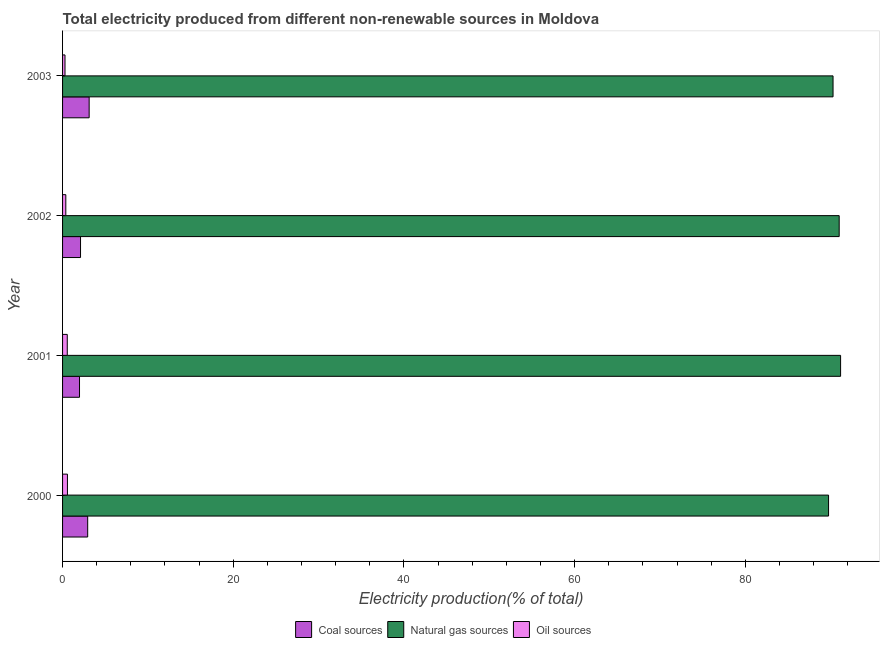How many different coloured bars are there?
Your answer should be very brief. 3. How many bars are there on the 2nd tick from the top?
Give a very brief answer. 3. How many bars are there on the 3rd tick from the bottom?
Keep it short and to the point. 3. What is the label of the 1st group of bars from the top?
Your response must be concise. 2003. In how many cases, is the number of bars for a given year not equal to the number of legend labels?
Keep it short and to the point. 0. What is the percentage of electricity produced by coal in 2001?
Your response must be concise. 1.99. Across all years, what is the maximum percentage of electricity produced by natural gas?
Give a very brief answer. 91.17. Across all years, what is the minimum percentage of electricity produced by natural gas?
Provide a succinct answer. 89.76. In which year was the percentage of electricity produced by oil sources maximum?
Your answer should be compact. 2000. What is the total percentage of electricity produced by natural gas in the graph?
Your response must be concise. 362.22. What is the difference between the percentage of electricity produced by coal in 2001 and that in 2002?
Provide a succinct answer. -0.12. What is the difference between the percentage of electricity produced by coal in 2000 and the percentage of electricity produced by natural gas in 2001?
Offer a very short reply. -88.23. What is the average percentage of electricity produced by coal per year?
Your answer should be very brief. 2.54. In the year 2000, what is the difference between the percentage of electricity produced by natural gas and percentage of electricity produced by oil sources?
Your answer should be very brief. 89.19. Is the percentage of electricity produced by oil sources in 2000 less than that in 2002?
Your answer should be very brief. No. Is the difference between the percentage of electricity produced by coal in 2001 and 2002 greater than the difference between the percentage of electricity produced by natural gas in 2001 and 2002?
Offer a very short reply. No. What is the difference between the highest and the second highest percentage of electricity produced by coal?
Offer a terse response. 0.17. What is the difference between the highest and the lowest percentage of electricity produced by coal?
Make the answer very short. 1.13. In how many years, is the percentage of electricity produced by natural gas greater than the average percentage of electricity produced by natural gas taken over all years?
Your answer should be compact. 2. What does the 2nd bar from the top in 2001 represents?
Provide a succinct answer. Natural gas sources. What does the 1st bar from the bottom in 2002 represents?
Keep it short and to the point. Coal sources. Are all the bars in the graph horizontal?
Give a very brief answer. Yes. How many years are there in the graph?
Provide a short and direct response. 4. What is the difference between two consecutive major ticks on the X-axis?
Your response must be concise. 20. Are the values on the major ticks of X-axis written in scientific E-notation?
Give a very brief answer. No. Does the graph contain any zero values?
Provide a succinct answer. No. How many legend labels are there?
Make the answer very short. 3. How are the legend labels stacked?
Give a very brief answer. Horizontal. What is the title of the graph?
Your response must be concise. Total electricity produced from different non-renewable sources in Moldova. What is the label or title of the X-axis?
Offer a terse response. Electricity production(% of total). What is the Electricity production(% of total) in Coal sources in 2000?
Ensure brevity in your answer.  2.94. What is the Electricity production(% of total) in Natural gas sources in 2000?
Offer a very short reply. 89.76. What is the Electricity production(% of total) in Oil sources in 2000?
Ensure brevity in your answer.  0.57. What is the Electricity production(% of total) in Coal sources in 2001?
Offer a terse response. 1.99. What is the Electricity production(% of total) in Natural gas sources in 2001?
Your answer should be compact. 91.17. What is the Electricity production(% of total) in Oil sources in 2001?
Ensure brevity in your answer.  0.55. What is the Electricity production(% of total) in Coal sources in 2002?
Offer a very short reply. 2.11. What is the Electricity production(% of total) in Natural gas sources in 2002?
Provide a short and direct response. 91.01. What is the Electricity production(% of total) in Oil sources in 2002?
Keep it short and to the point. 0.38. What is the Electricity production(% of total) of Coal sources in 2003?
Your response must be concise. 3.12. What is the Electricity production(% of total) of Natural gas sources in 2003?
Ensure brevity in your answer.  90.29. What is the Electricity production(% of total) in Oil sources in 2003?
Offer a very short reply. 0.28. Across all years, what is the maximum Electricity production(% of total) of Coal sources?
Offer a terse response. 3.12. Across all years, what is the maximum Electricity production(% of total) in Natural gas sources?
Your response must be concise. 91.17. Across all years, what is the maximum Electricity production(% of total) of Oil sources?
Ensure brevity in your answer.  0.57. Across all years, what is the minimum Electricity production(% of total) of Coal sources?
Your response must be concise. 1.99. Across all years, what is the minimum Electricity production(% of total) in Natural gas sources?
Keep it short and to the point. 89.76. Across all years, what is the minimum Electricity production(% of total) in Oil sources?
Ensure brevity in your answer.  0.28. What is the total Electricity production(% of total) of Coal sources in the graph?
Ensure brevity in your answer.  10.15. What is the total Electricity production(% of total) in Natural gas sources in the graph?
Ensure brevity in your answer.  362.22. What is the total Electricity production(% of total) of Oil sources in the graph?
Offer a very short reply. 1.79. What is the difference between the Electricity production(% of total) of Coal sources in 2000 and that in 2001?
Ensure brevity in your answer.  0.96. What is the difference between the Electricity production(% of total) of Natural gas sources in 2000 and that in 2001?
Your answer should be compact. -1.41. What is the difference between the Electricity production(% of total) of Coal sources in 2000 and that in 2002?
Provide a short and direct response. 0.84. What is the difference between the Electricity production(% of total) in Natural gas sources in 2000 and that in 2002?
Your answer should be compact. -1.25. What is the difference between the Electricity production(% of total) in Oil sources in 2000 and that in 2002?
Your response must be concise. 0.19. What is the difference between the Electricity production(% of total) of Coal sources in 2000 and that in 2003?
Keep it short and to the point. -0.17. What is the difference between the Electricity production(% of total) of Natural gas sources in 2000 and that in 2003?
Your response must be concise. -0.53. What is the difference between the Electricity production(% of total) in Oil sources in 2000 and that in 2003?
Your response must be concise. 0.29. What is the difference between the Electricity production(% of total) in Coal sources in 2001 and that in 2002?
Your answer should be compact. -0.12. What is the difference between the Electricity production(% of total) of Natural gas sources in 2001 and that in 2002?
Your answer should be compact. 0.16. What is the difference between the Electricity production(% of total) in Oil sources in 2001 and that in 2002?
Your response must be concise. 0.17. What is the difference between the Electricity production(% of total) in Coal sources in 2001 and that in 2003?
Ensure brevity in your answer.  -1.13. What is the difference between the Electricity production(% of total) in Natural gas sources in 2001 and that in 2003?
Offer a very short reply. 0.88. What is the difference between the Electricity production(% of total) in Oil sources in 2001 and that in 2003?
Offer a terse response. 0.27. What is the difference between the Electricity production(% of total) in Coal sources in 2002 and that in 2003?
Give a very brief answer. -1.01. What is the difference between the Electricity production(% of total) of Natural gas sources in 2002 and that in 2003?
Your answer should be compact. 0.72. What is the difference between the Electricity production(% of total) in Oil sources in 2002 and that in 2003?
Keep it short and to the point. 0.1. What is the difference between the Electricity production(% of total) of Coal sources in 2000 and the Electricity production(% of total) of Natural gas sources in 2001?
Your answer should be very brief. -88.23. What is the difference between the Electricity production(% of total) of Coal sources in 2000 and the Electricity production(% of total) of Oil sources in 2001?
Provide a succinct answer. 2.39. What is the difference between the Electricity production(% of total) of Natural gas sources in 2000 and the Electricity production(% of total) of Oil sources in 2001?
Your response must be concise. 89.21. What is the difference between the Electricity production(% of total) in Coal sources in 2000 and the Electricity production(% of total) in Natural gas sources in 2002?
Offer a terse response. -88.06. What is the difference between the Electricity production(% of total) in Coal sources in 2000 and the Electricity production(% of total) in Oil sources in 2002?
Offer a terse response. 2.56. What is the difference between the Electricity production(% of total) of Natural gas sources in 2000 and the Electricity production(% of total) of Oil sources in 2002?
Offer a very short reply. 89.38. What is the difference between the Electricity production(% of total) of Coal sources in 2000 and the Electricity production(% of total) of Natural gas sources in 2003?
Offer a very short reply. -87.34. What is the difference between the Electricity production(% of total) in Coal sources in 2000 and the Electricity production(% of total) in Oil sources in 2003?
Offer a very short reply. 2.66. What is the difference between the Electricity production(% of total) of Natural gas sources in 2000 and the Electricity production(% of total) of Oil sources in 2003?
Your answer should be very brief. 89.48. What is the difference between the Electricity production(% of total) of Coal sources in 2001 and the Electricity production(% of total) of Natural gas sources in 2002?
Make the answer very short. -89.02. What is the difference between the Electricity production(% of total) in Coal sources in 2001 and the Electricity production(% of total) in Oil sources in 2002?
Provide a short and direct response. 1.61. What is the difference between the Electricity production(% of total) in Natural gas sources in 2001 and the Electricity production(% of total) in Oil sources in 2002?
Ensure brevity in your answer.  90.79. What is the difference between the Electricity production(% of total) of Coal sources in 2001 and the Electricity production(% of total) of Natural gas sources in 2003?
Your answer should be compact. -88.3. What is the difference between the Electricity production(% of total) of Coal sources in 2001 and the Electricity production(% of total) of Oil sources in 2003?
Provide a short and direct response. 1.7. What is the difference between the Electricity production(% of total) in Natural gas sources in 2001 and the Electricity production(% of total) in Oil sources in 2003?
Keep it short and to the point. 90.89. What is the difference between the Electricity production(% of total) of Coal sources in 2002 and the Electricity production(% of total) of Natural gas sources in 2003?
Offer a very short reply. -88.18. What is the difference between the Electricity production(% of total) of Coal sources in 2002 and the Electricity production(% of total) of Oil sources in 2003?
Provide a short and direct response. 1.82. What is the difference between the Electricity production(% of total) of Natural gas sources in 2002 and the Electricity production(% of total) of Oil sources in 2003?
Provide a succinct answer. 90.72. What is the average Electricity production(% of total) in Coal sources per year?
Your answer should be compact. 2.54. What is the average Electricity production(% of total) in Natural gas sources per year?
Your response must be concise. 90.56. What is the average Electricity production(% of total) in Oil sources per year?
Ensure brevity in your answer.  0.45. In the year 2000, what is the difference between the Electricity production(% of total) of Coal sources and Electricity production(% of total) of Natural gas sources?
Your response must be concise. -86.82. In the year 2000, what is the difference between the Electricity production(% of total) in Coal sources and Electricity production(% of total) in Oil sources?
Provide a short and direct response. 2.37. In the year 2000, what is the difference between the Electricity production(% of total) of Natural gas sources and Electricity production(% of total) of Oil sources?
Provide a succinct answer. 89.19. In the year 2001, what is the difference between the Electricity production(% of total) of Coal sources and Electricity production(% of total) of Natural gas sources?
Keep it short and to the point. -89.18. In the year 2001, what is the difference between the Electricity production(% of total) of Coal sources and Electricity production(% of total) of Oil sources?
Make the answer very short. 1.44. In the year 2001, what is the difference between the Electricity production(% of total) in Natural gas sources and Electricity production(% of total) in Oil sources?
Ensure brevity in your answer.  90.62. In the year 2002, what is the difference between the Electricity production(% of total) of Coal sources and Electricity production(% of total) of Natural gas sources?
Keep it short and to the point. -88.9. In the year 2002, what is the difference between the Electricity production(% of total) in Coal sources and Electricity production(% of total) in Oil sources?
Your answer should be very brief. 1.73. In the year 2002, what is the difference between the Electricity production(% of total) of Natural gas sources and Electricity production(% of total) of Oil sources?
Ensure brevity in your answer.  90.63. In the year 2003, what is the difference between the Electricity production(% of total) of Coal sources and Electricity production(% of total) of Natural gas sources?
Keep it short and to the point. -87.17. In the year 2003, what is the difference between the Electricity production(% of total) of Coal sources and Electricity production(% of total) of Oil sources?
Your answer should be compact. 2.83. In the year 2003, what is the difference between the Electricity production(% of total) in Natural gas sources and Electricity production(% of total) in Oil sources?
Give a very brief answer. 90. What is the ratio of the Electricity production(% of total) of Coal sources in 2000 to that in 2001?
Ensure brevity in your answer.  1.48. What is the ratio of the Electricity production(% of total) of Natural gas sources in 2000 to that in 2001?
Your answer should be very brief. 0.98. What is the ratio of the Electricity production(% of total) of Oil sources in 2000 to that in 2001?
Provide a succinct answer. 1.04. What is the ratio of the Electricity production(% of total) of Coal sources in 2000 to that in 2002?
Make the answer very short. 1.4. What is the ratio of the Electricity production(% of total) of Natural gas sources in 2000 to that in 2002?
Your answer should be very brief. 0.99. What is the ratio of the Electricity production(% of total) of Oil sources in 2000 to that in 2002?
Provide a succinct answer. 1.5. What is the ratio of the Electricity production(% of total) of Coal sources in 2000 to that in 2003?
Your answer should be very brief. 0.94. What is the ratio of the Electricity production(% of total) of Natural gas sources in 2000 to that in 2003?
Keep it short and to the point. 0.99. What is the ratio of the Electricity production(% of total) of Oil sources in 2000 to that in 2003?
Provide a short and direct response. 2. What is the ratio of the Electricity production(% of total) of Coal sources in 2001 to that in 2002?
Your answer should be compact. 0.94. What is the ratio of the Electricity production(% of total) of Natural gas sources in 2001 to that in 2002?
Provide a short and direct response. 1. What is the ratio of the Electricity production(% of total) of Oil sources in 2001 to that in 2002?
Offer a very short reply. 1.45. What is the ratio of the Electricity production(% of total) in Coal sources in 2001 to that in 2003?
Keep it short and to the point. 0.64. What is the ratio of the Electricity production(% of total) of Natural gas sources in 2001 to that in 2003?
Keep it short and to the point. 1.01. What is the ratio of the Electricity production(% of total) of Oil sources in 2001 to that in 2003?
Ensure brevity in your answer.  1.93. What is the ratio of the Electricity production(% of total) in Coal sources in 2002 to that in 2003?
Offer a very short reply. 0.68. What is the ratio of the Electricity production(% of total) in Natural gas sources in 2002 to that in 2003?
Offer a very short reply. 1.01. What is the ratio of the Electricity production(% of total) of Oil sources in 2002 to that in 2003?
Ensure brevity in your answer.  1.33. What is the difference between the highest and the second highest Electricity production(% of total) of Coal sources?
Give a very brief answer. 0.17. What is the difference between the highest and the second highest Electricity production(% of total) in Natural gas sources?
Make the answer very short. 0.16. What is the difference between the highest and the lowest Electricity production(% of total) of Coal sources?
Make the answer very short. 1.13. What is the difference between the highest and the lowest Electricity production(% of total) of Natural gas sources?
Your response must be concise. 1.41. What is the difference between the highest and the lowest Electricity production(% of total) of Oil sources?
Provide a succinct answer. 0.29. 